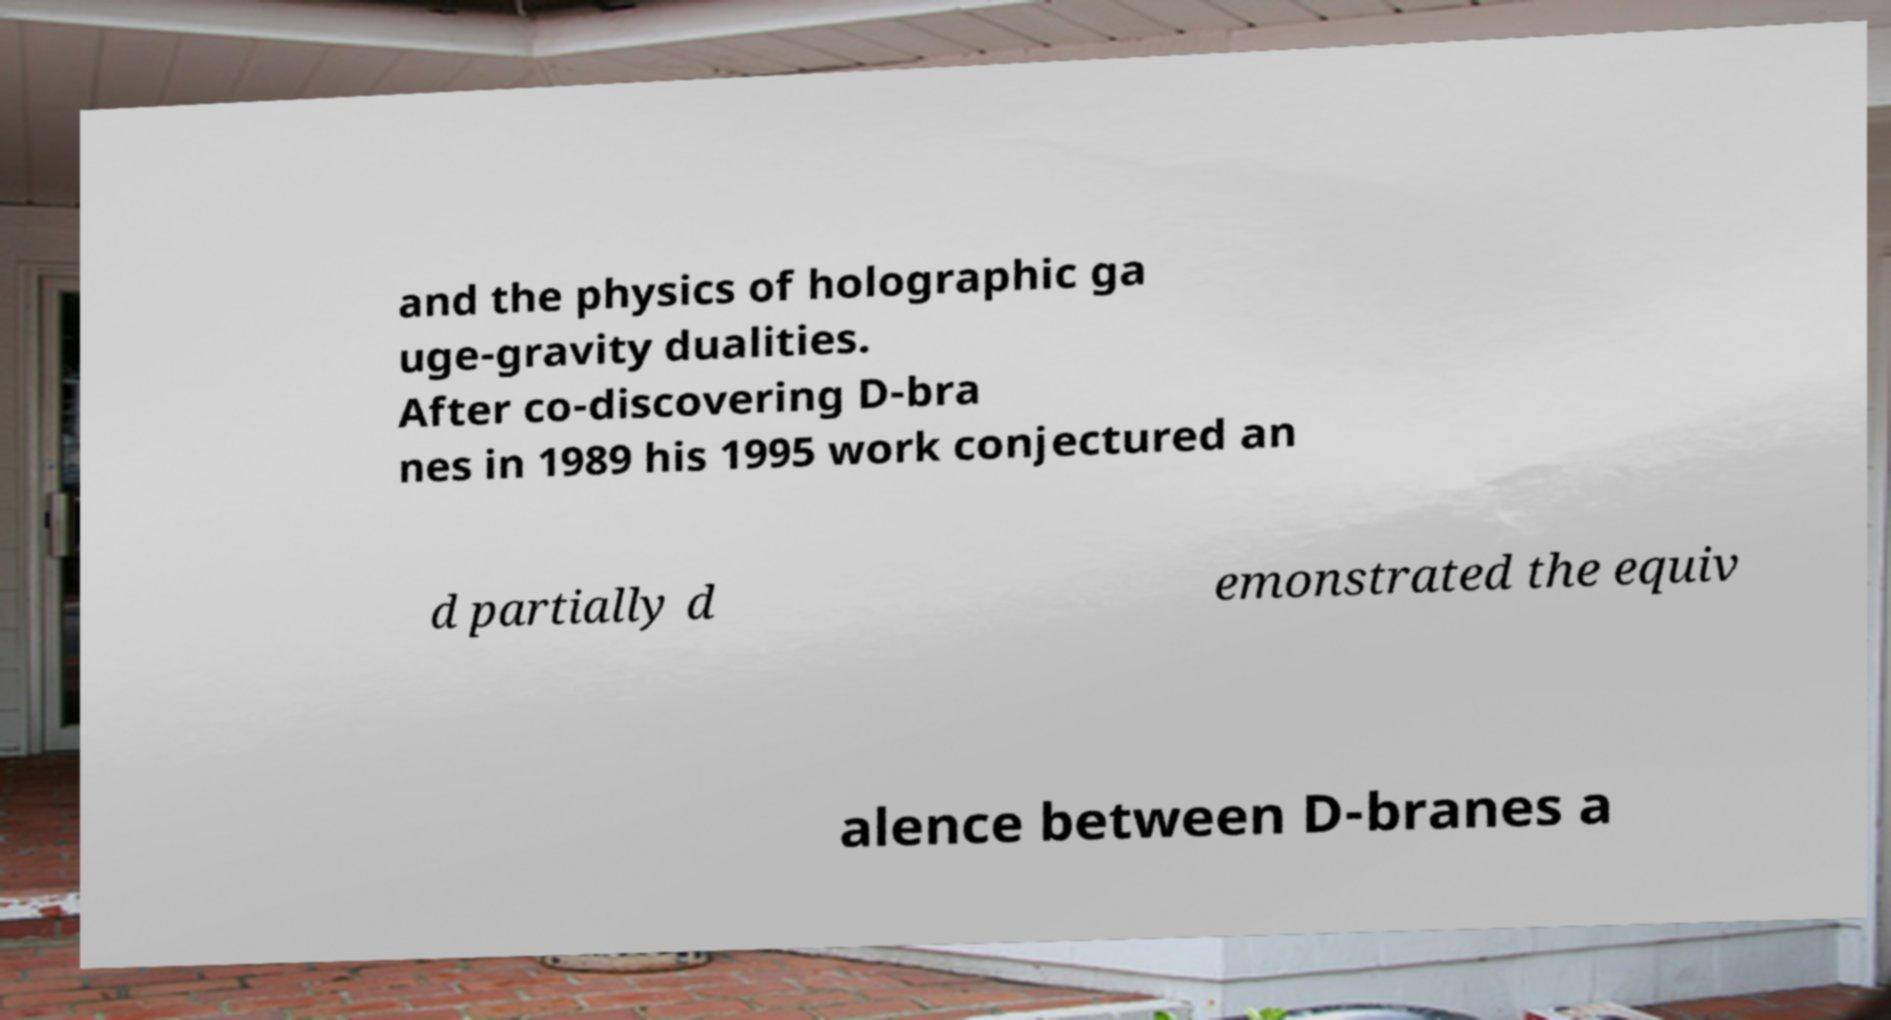What messages or text are displayed in this image? I need them in a readable, typed format. and the physics of holographic ga uge-gravity dualities. After co-discovering D-bra nes in 1989 his 1995 work conjectured an d partially d emonstrated the equiv alence between D-branes a 